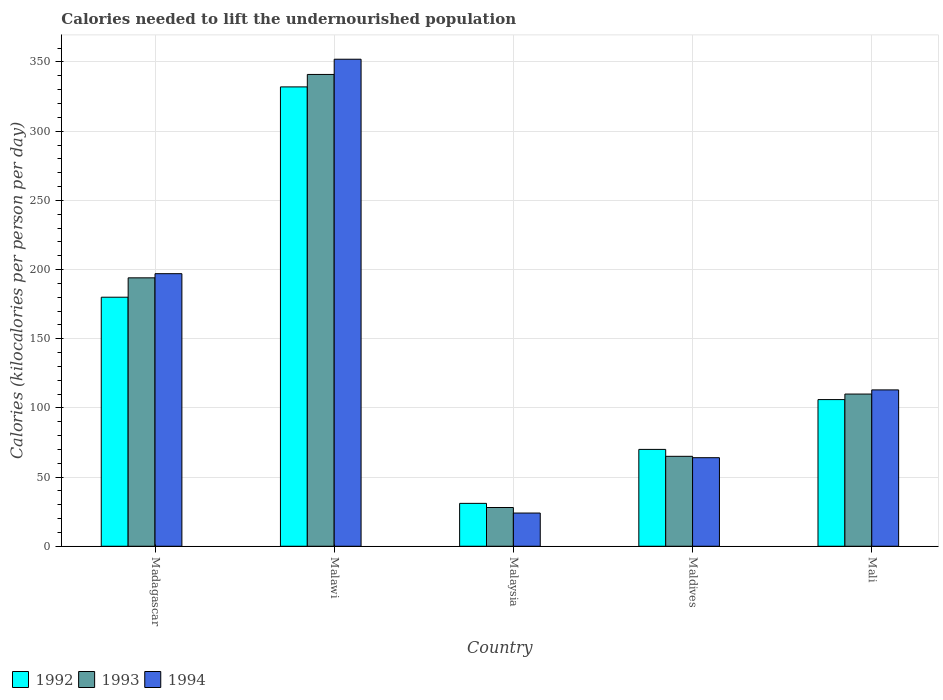How many different coloured bars are there?
Your response must be concise. 3. How many groups of bars are there?
Your answer should be compact. 5. Are the number of bars per tick equal to the number of legend labels?
Give a very brief answer. Yes. How many bars are there on the 5th tick from the right?
Make the answer very short. 3. What is the label of the 5th group of bars from the left?
Your answer should be very brief. Mali. In how many cases, is the number of bars for a given country not equal to the number of legend labels?
Provide a short and direct response. 0. What is the total calories needed to lift the undernourished population in 1992 in Maldives?
Offer a very short reply. 70. Across all countries, what is the maximum total calories needed to lift the undernourished population in 1992?
Ensure brevity in your answer.  332. Across all countries, what is the minimum total calories needed to lift the undernourished population in 1994?
Keep it short and to the point. 24. In which country was the total calories needed to lift the undernourished population in 1993 maximum?
Your answer should be very brief. Malawi. In which country was the total calories needed to lift the undernourished population in 1993 minimum?
Provide a succinct answer. Malaysia. What is the total total calories needed to lift the undernourished population in 1992 in the graph?
Provide a succinct answer. 719. What is the difference between the total calories needed to lift the undernourished population in 1994 in Malawi and that in Malaysia?
Your answer should be compact. 328. What is the difference between the total calories needed to lift the undernourished population in 1992 in Madagascar and the total calories needed to lift the undernourished population in 1994 in Maldives?
Provide a short and direct response. 116. What is the average total calories needed to lift the undernourished population in 1992 per country?
Your response must be concise. 143.8. What is the difference between the total calories needed to lift the undernourished population of/in 1994 and total calories needed to lift the undernourished population of/in 1993 in Maldives?
Provide a short and direct response. -1. In how many countries, is the total calories needed to lift the undernourished population in 1992 greater than 290 kilocalories?
Your answer should be compact. 1. What is the ratio of the total calories needed to lift the undernourished population in 1992 in Malawi to that in Maldives?
Your response must be concise. 4.74. Is the total calories needed to lift the undernourished population in 1994 in Madagascar less than that in Maldives?
Offer a very short reply. No. Is the difference between the total calories needed to lift the undernourished population in 1994 in Maldives and Mali greater than the difference between the total calories needed to lift the undernourished population in 1993 in Maldives and Mali?
Offer a very short reply. No. What is the difference between the highest and the second highest total calories needed to lift the undernourished population in 1994?
Give a very brief answer. 239. What is the difference between the highest and the lowest total calories needed to lift the undernourished population in 1992?
Offer a terse response. 301. What does the 1st bar from the left in Malawi represents?
Ensure brevity in your answer.  1992. What does the 1st bar from the right in Madagascar represents?
Give a very brief answer. 1994. How many bars are there?
Provide a short and direct response. 15. Are all the bars in the graph horizontal?
Your response must be concise. No. Where does the legend appear in the graph?
Provide a short and direct response. Bottom left. How are the legend labels stacked?
Your answer should be very brief. Horizontal. What is the title of the graph?
Give a very brief answer. Calories needed to lift the undernourished population. Does "2008" appear as one of the legend labels in the graph?
Keep it short and to the point. No. What is the label or title of the Y-axis?
Your answer should be compact. Calories (kilocalories per person per day). What is the Calories (kilocalories per person per day) in 1992 in Madagascar?
Offer a very short reply. 180. What is the Calories (kilocalories per person per day) of 1993 in Madagascar?
Your response must be concise. 194. What is the Calories (kilocalories per person per day) in 1994 in Madagascar?
Offer a terse response. 197. What is the Calories (kilocalories per person per day) in 1992 in Malawi?
Your answer should be compact. 332. What is the Calories (kilocalories per person per day) of 1993 in Malawi?
Your answer should be compact. 341. What is the Calories (kilocalories per person per day) of 1994 in Malawi?
Provide a succinct answer. 352. What is the Calories (kilocalories per person per day) in 1994 in Maldives?
Give a very brief answer. 64. What is the Calories (kilocalories per person per day) in 1992 in Mali?
Give a very brief answer. 106. What is the Calories (kilocalories per person per day) of 1993 in Mali?
Make the answer very short. 110. What is the Calories (kilocalories per person per day) of 1994 in Mali?
Provide a short and direct response. 113. Across all countries, what is the maximum Calories (kilocalories per person per day) of 1992?
Your answer should be very brief. 332. Across all countries, what is the maximum Calories (kilocalories per person per day) of 1993?
Provide a short and direct response. 341. Across all countries, what is the maximum Calories (kilocalories per person per day) of 1994?
Provide a succinct answer. 352. Across all countries, what is the minimum Calories (kilocalories per person per day) in 1992?
Provide a succinct answer. 31. Across all countries, what is the minimum Calories (kilocalories per person per day) of 1993?
Give a very brief answer. 28. What is the total Calories (kilocalories per person per day) in 1992 in the graph?
Provide a short and direct response. 719. What is the total Calories (kilocalories per person per day) in 1993 in the graph?
Provide a short and direct response. 738. What is the total Calories (kilocalories per person per day) in 1994 in the graph?
Give a very brief answer. 750. What is the difference between the Calories (kilocalories per person per day) in 1992 in Madagascar and that in Malawi?
Give a very brief answer. -152. What is the difference between the Calories (kilocalories per person per day) of 1993 in Madagascar and that in Malawi?
Your answer should be compact. -147. What is the difference between the Calories (kilocalories per person per day) in 1994 in Madagascar and that in Malawi?
Offer a terse response. -155. What is the difference between the Calories (kilocalories per person per day) in 1992 in Madagascar and that in Malaysia?
Keep it short and to the point. 149. What is the difference between the Calories (kilocalories per person per day) in 1993 in Madagascar and that in Malaysia?
Provide a short and direct response. 166. What is the difference between the Calories (kilocalories per person per day) in 1994 in Madagascar and that in Malaysia?
Ensure brevity in your answer.  173. What is the difference between the Calories (kilocalories per person per day) of 1992 in Madagascar and that in Maldives?
Your answer should be very brief. 110. What is the difference between the Calories (kilocalories per person per day) of 1993 in Madagascar and that in Maldives?
Give a very brief answer. 129. What is the difference between the Calories (kilocalories per person per day) of 1994 in Madagascar and that in Maldives?
Make the answer very short. 133. What is the difference between the Calories (kilocalories per person per day) of 1993 in Madagascar and that in Mali?
Keep it short and to the point. 84. What is the difference between the Calories (kilocalories per person per day) of 1994 in Madagascar and that in Mali?
Provide a short and direct response. 84. What is the difference between the Calories (kilocalories per person per day) in 1992 in Malawi and that in Malaysia?
Your answer should be compact. 301. What is the difference between the Calories (kilocalories per person per day) in 1993 in Malawi and that in Malaysia?
Provide a succinct answer. 313. What is the difference between the Calories (kilocalories per person per day) in 1994 in Malawi and that in Malaysia?
Offer a terse response. 328. What is the difference between the Calories (kilocalories per person per day) of 1992 in Malawi and that in Maldives?
Provide a succinct answer. 262. What is the difference between the Calories (kilocalories per person per day) of 1993 in Malawi and that in Maldives?
Keep it short and to the point. 276. What is the difference between the Calories (kilocalories per person per day) of 1994 in Malawi and that in Maldives?
Your answer should be compact. 288. What is the difference between the Calories (kilocalories per person per day) in 1992 in Malawi and that in Mali?
Offer a terse response. 226. What is the difference between the Calories (kilocalories per person per day) of 1993 in Malawi and that in Mali?
Keep it short and to the point. 231. What is the difference between the Calories (kilocalories per person per day) in 1994 in Malawi and that in Mali?
Ensure brevity in your answer.  239. What is the difference between the Calories (kilocalories per person per day) of 1992 in Malaysia and that in Maldives?
Ensure brevity in your answer.  -39. What is the difference between the Calories (kilocalories per person per day) of 1993 in Malaysia and that in Maldives?
Give a very brief answer. -37. What is the difference between the Calories (kilocalories per person per day) in 1994 in Malaysia and that in Maldives?
Offer a terse response. -40. What is the difference between the Calories (kilocalories per person per day) of 1992 in Malaysia and that in Mali?
Make the answer very short. -75. What is the difference between the Calories (kilocalories per person per day) in 1993 in Malaysia and that in Mali?
Give a very brief answer. -82. What is the difference between the Calories (kilocalories per person per day) of 1994 in Malaysia and that in Mali?
Provide a succinct answer. -89. What is the difference between the Calories (kilocalories per person per day) of 1992 in Maldives and that in Mali?
Provide a succinct answer. -36. What is the difference between the Calories (kilocalories per person per day) of 1993 in Maldives and that in Mali?
Give a very brief answer. -45. What is the difference between the Calories (kilocalories per person per day) of 1994 in Maldives and that in Mali?
Ensure brevity in your answer.  -49. What is the difference between the Calories (kilocalories per person per day) of 1992 in Madagascar and the Calories (kilocalories per person per day) of 1993 in Malawi?
Keep it short and to the point. -161. What is the difference between the Calories (kilocalories per person per day) of 1992 in Madagascar and the Calories (kilocalories per person per day) of 1994 in Malawi?
Provide a short and direct response. -172. What is the difference between the Calories (kilocalories per person per day) of 1993 in Madagascar and the Calories (kilocalories per person per day) of 1994 in Malawi?
Ensure brevity in your answer.  -158. What is the difference between the Calories (kilocalories per person per day) of 1992 in Madagascar and the Calories (kilocalories per person per day) of 1993 in Malaysia?
Keep it short and to the point. 152. What is the difference between the Calories (kilocalories per person per day) of 1992 in Madagascar and the Calories (kilocalories per person per day) of 1994 in Malaysia?
Your answer should be compact. 156. What is the difference between the Calories (kilocalories per person per day) in 1993 in Madagascar and the Calories (kilocalories per person per day) in 1994 in Malaysia?
Ensure brevity in your answer.  170. What is the difference between the Calories (kilocalories per person per day) of 1992 in Madagascar and the Calories (kilocalories per person per day) of 1993 in Maldives?
Your response must be concise. 115. What is the difference between the Calories (kilocalories per person per day) in 1992 in Madagascar and the Calories (kilocalories per person per day) in 1994 in Maldives?
Make the answer very short. 116. What is the difference between the Calories (kilocalories per person per day) of 1993 in Madagascar and the Calories (kilocalories per person per day) of 1994 in Maldives?
Provide a succinct answer. 130. What is the difference between the Calories (kilocalories per person per day) of 1992 in Madagascar and the Calories (kilocalories per person per day) of 1993 in Mali?
Your response must be concise. 70. What is the difference between the Calories (kilocalories per person per day) of 1992 in Madagascar and the Calories (kilocalories per person per day) of 1994 in Mali?
Offer a very short reply. 67. What is the difference between the Calories (kilocalories per person per day) in 1992 in Malawi and the Calories (kilocalories per person per day) in 1993 in Malaysia?
Your response must be concise. 304. What is the difference between the Calories (kilocalories per person per day) in 1992 in Malawi and the Calories (kilocalories per person per day) in 1994 in Malaysia?
Your response must be concise. 308. What is the difference between the Calories (kilocalories per person per day) of 1993 in Malawi and the Calories (kilocalories per person per day) of 1994 in Malaysia?
Your answer should be compact. 317. What is the difference between the Calories (kilocalories per person per day) in 1992 in Malawi and the Calories (kilocalories per person per day) in 1993 in Maldives?
Your response must be concise. 267. What is the difference between the Calories (kilocalories per person per day) in 1992 in Malawi and the Calories (kilocalories per person per day) in 1994 in Maldives?
Your response must be concise. 268. What is the difference between the Calories (kilocalories per person per day) of 1993 in Malawi and the Calories (kilocalories per person per day) of 1994 in Maldives?
Your response must be concise. 277. What is the difference between the Calories (kilocalories per person per day) of 1992 in Malawi and the Calories (kilocalories per person per day) of 1993 in Mali?
Keep it short and to the point. 222. What is the difference between the Calories (kilocalories per person per day) of 1992 in Malawi and the Calories (kilocalories per person per day) of 1994 in Mali?
Offer a very short reply. 219. What is the difference between the Calories (kilocalories per person per day) of 1993 in Malawi and the Calories (kilocalories per person per day) of 1994 in Mali?
Provide a short and direct response. 228. What is the difference between the Calories (kilocalories per person per day) of 1992 in Malaysia and the Calories (kilocalories per person per day) of 1993 in Maldives?
Your answer should be compact. -34. What is the difference between the Calories (kilocalories per person per day) of 1992 in Malaysia and the Calories (kilocalories per person per day) of 1994 in Maldives?
Make the answer very short. -33. What is the difference between the Calories (kilocalories per person per day) in 1993 in Malaysia and the Calories (kilocalories per person per day) in 1994 in Maldives?
Offer a very short reply. -36. What is the difference between the Calories (kilocalories per person per day) of 1992 in Malaysia and the Calories (kilocalories per person per day) of 1993 in Mali?
Offer a terse response. -79. What is the difference between the Calories (kilocalories per person per day) of 1992 in Malaysia and the Calories (kilocalories per person per day) of 1994 in Mali?
Give a very brief answer. -82. What is the difference between the Calories (kilocalories per person per day) of 1993 in Malaysia and the Calories (kilocalories per person per day) of 1994 in Mali?
Offer a terse response. -85. What is the difference between the Calories (kilocalories per person per day) in 1992 in Maldives and the Calories (kilocalories per person per day) in 1993 in Mali?
Offer a very short reply. -40. What is the difference between the Calories (kilocalories per person per day) in 1992 in Maldives and the Calories (kilocalories per person per day) in 1994 in Mali?
Offer a very short reply. -43. What is the difference between the Calories (kilocalories per person per day) in 1993 in Maldives and the Calories (kilocalories per person per day) in 1994 in Mali?
Ensure brevity in your answer.  -48. What is the average Calories (kilocalories per person per day) of 1992 per country?
Keep it short and to the point. 143.8. What is the average Calories (kilocalories per person per day) in 1993 per country?
Your response must be concise. 147.6. What is the average Calories (kilocalories per person per day) of 1994 per country?
Your response must be concise. 150. What is the difference between the Calories (kilocalories per person per day) in 1992 and Calories (kilocalories per person per day) in 1993 in Madagascar?
Provide a succinct answer. -14. What is the difference between the Calories (kilocalories per person per day) in 1993 and Calories (kilocalories per person per day) in 1994 in Madagascar?
Your answer should be very brief. -3. What is the difference between the Calories (kilocalories per person per day) of 1992 and Calories (kilocalories per person per day) of 1993 in Malawi?
Keep it short and to the point. -9. What is the difference between the Calories (kilocalories per person per day) in 1992 and Calories (kilocalories per person per day) in 1994 in Malawi?
Offer a terse response. -20. What is the difference between the Calories (kilocalories per person per day) in 1992 and Calories (kilocalories per person per day) in 1993 in Malaysia?
Your response must be concise. 3. What is the difference between the Calories (kilocalories per person per day) of 1992 and Calories (kilocalories per person per day) of 1994 in Malaysia?
Keep it short and to the point. 7. What is the difference between the Calories (kilocalories per person per day) in 1993 and Calories (kilocalories per person per day) in 1994 in Malaysia?
Your answer should be compact. 4. What is the difference between the Calories (kilocalories per person per day) of 1992 and Calories (kilocalories per person per day) of 1993 in Maldives?
Offer a very short reply. 5. What is the difference between the Calories (kilocalories per person per day) in 1992 and Calories (kilocalories per person per day) in 1994 in Maldives?
Keep it short and to the point. 6. What is the difference between the Calories (kilocalories per person per day) in 1993 and Calories (kilocalories per person per day) in 1994 in Maldives?
Keep it short and to the point. 1. What is the ratio of the Calories (kilocalories per person per day) of 1992 in Madagascar to that in Malawi?
Your answer should be compact. 0.54. What is the ratio of the Calories (kilocalories per person per day) in 1993 in Madagascar to that in Malawi?
Ensure brevity in your answer.  0.57. What is the ratio of the Calories (kilocalories per person per day) in 1994 in Madagascar to that in Malawi?
Keep it short and to the point. 0.56. What is the ratio of the Calories (kilocalories per person per day) of 1992 in Madagascar to that in Malaysia?
Provide a succinct answer. 5.81. What is the ratio of the Calories (kilocalories per person per day) in 1993 in Madagascar to that in Malaysia?
Provide a short and direct response. 6.93. What is the ratio of the Calories (kilocalories per person per day) of 1994 in Madagascar to that in Malaysia?
Offer a terse response. 8.21. What is the ratio of the Calories (kilocalories per person per day) of 1992 in Madagascar to that in Maldives?
Keep it short and to the point. 2.57. What is the ratio of the Calories (kilocalories per person per day) of 1993 in Madagascar to that in Maldives?
Give a very brief answer. 2.98. What is the ratio of the Calories (kilocalories per person per day) in 1994 in Madagascar to that in Maldives?
Make the answer very short. 3.08. What is the ratio of the Calories (kilocalories per person per day) of 1992 in Madagascar to that in Mali?
Offer a very short reply. 1.7. What is the ratio of the Calories (kilocalories per person per day) in 1993 in Madagascar to that in Mali?
Offer a terse response. 1.76. What is the ratio of the Calories (kilocalories per person per day) in 1994 in Madagascar to that in Mali?
Make the answer very short. 1.74. What is the ratio of the Calories (kilocalories per person per day) in 1992 in Malawi to that in Malaysia?
Offer a very short reply. 10.71. What is the ratio of the Calories (kilocalories per person per day) of 1993 in Malawi to that in Malaysia?
Give a very brief answer. 12.18. What is the ratio of the Calories (kilocalories per person per day) in 1994 in Malawi to that in Malaysia?
Your answer should be very brief. 14.67. What is the ratio of the Calories (kilocalories per person per day) of 1992 in Malawi to that in Maldives?
Keep it short and to the point. 4.74. What is the ratio of the Calories (kilocalories per person per day) of 1993 in Malawi to that in Maldives?
Provide a succinct answer. 5.25. What is the ratio of the Calories (kilocalories per person per day) in 1992 in Malawi to that in Mali?
Offer a terse response. 3.13. What is the ratio of the Calories (kilocalories per person per day) in 1993 in Malawi to that in Mali?
Give a very brief answer. 3.1. What is the ratio of the Calories (kilocalories per person per day) of 1994 in Malawi to that in Mali?
Your answer should be very brief. 3.12. What is the ratio of the Calories (kilocalories per person per day) in 1992 in Malaysia to that in Maldives?
Make the answer very short. 0.44. What is the ratio of the Calories (kilocalories per person per day) in 1993 in Malaysia to that in Maldives?
Your answer should be compact. 0.43. What is the ratio of the Calories (kilocalories per person per day) of 1994 in Malaysia to that in Maldives?
Provide a succinct answer. 0.38. What is the ratio of the Calories (kilocalories per person per day) of 1992 in Malaysia to that in Mali?
Offer a very short reply. 0.29. What is the ratio of the Calories (kilocalories per person per day) of 1993 in Malaysia to that in Mali?
Provide a short and direct response. 0.25. What is the ratio of the Calories (kilocalories per person per day) in 1994 in Malaysia to that in Mali?
Make the answer very short. 0.21. What is the ratio of the Calories (kilocalories per person per day) in 1992 in Maldives to that in Mali?
Your response must be concise. 0.66. What is the ratio of the Calories (kilocalories per person per day) of 1993 in Maldives to that in Mali?
Your answer should be very brief. 0.59. What is the ratio of the Calories (kilocalories per person per day) of 1994 in Maldives to that in Mali?
Ensure brevity in your answer.  0.57. What is the difference between the highest and the second highest Calories (kilocalories per person per day) in 1992?
Ensure brevity in your answer.  152. What is the difference between the highest and the second highest Calories (kilocalories per person per day) in 1993?
Provide a succinct answer. 147. What is the difference between the highest and the second highest Calories (kilocalories per person per day) of 1994?
Provide a short and direct response. 155. What is the difference between the highest and the lowest Calories (kilocalories per person per day) of 1992?
Give a very brief answer. 301. What is the difference between the highest and the lowest Calories (kilocalories per person per day) of 1993?
Your response must be concise. 313. What is the difference between the highest and the lowest Calories (kilocalories per person per day) in 1994?
Make the answer very short. 328. 